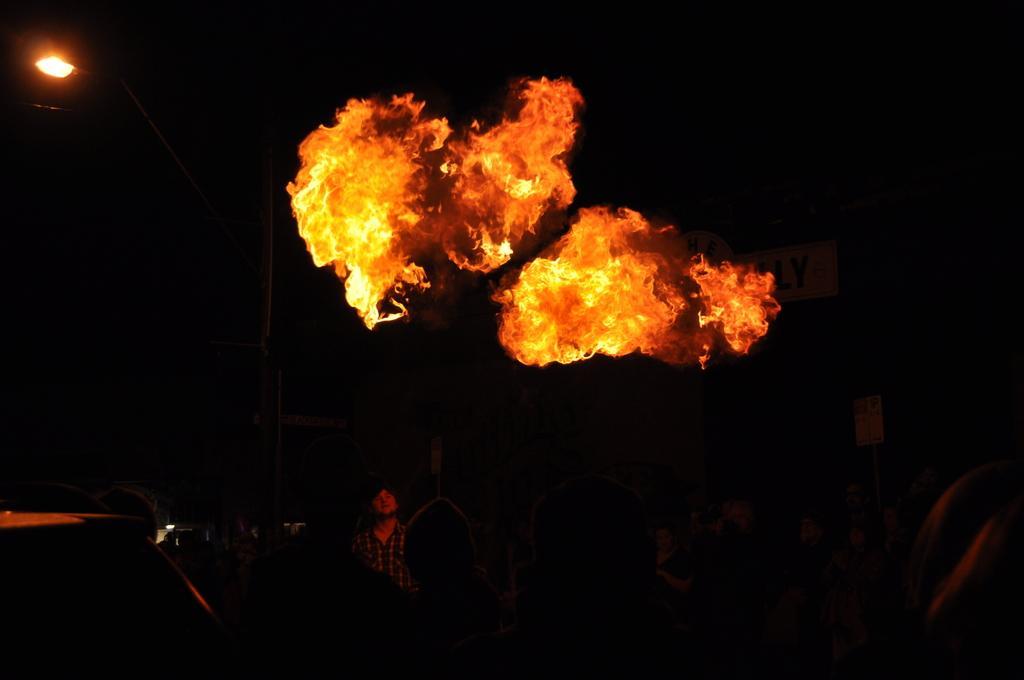Describe this image in one or two sentences. In the middle of the image, there is fire. Below this, there is a person. In the background, there is a light. And the background is dark in color. 